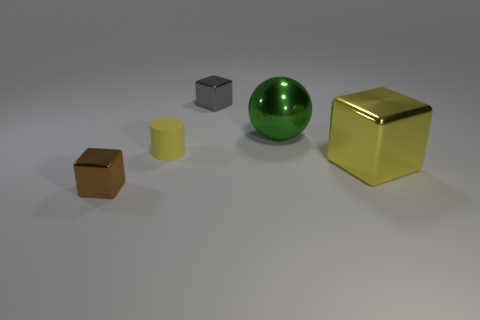Add 1 small yellow metallic objects. How many objects exist? 6 Subtract all balls. How many objects are left? 4 Subtract all gray blocks. Subtract all yellow matte objects. How many objects are left? 3 Add 3 yellow cubes. How many yellow cubes are left? 4 Add 5 small blocks. How many small blocks exist? 7 Subtract 0 green cylinders. How many objects are left? 5 